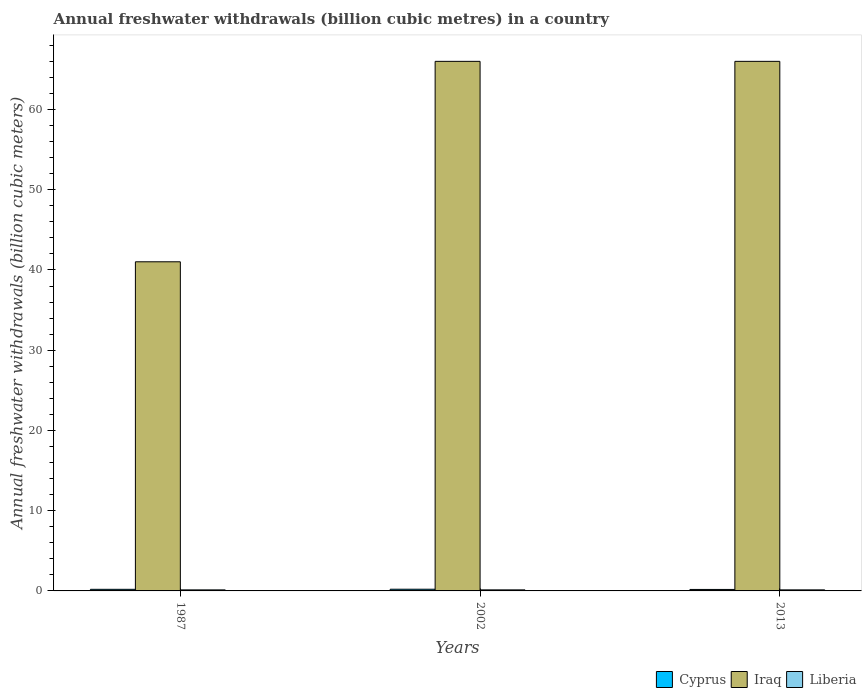How many different coloured bars are there?
Make the answer very short. 3. Are the number of bars per tick equal to the number of legend labels?
Provide a succinct answer. Yes. How many bars are there on the 3rd tick from the left?
Make the answer very short. 3. How many bars are there on the 1st tick from the right?
Your answer should be very brief. 3. In how many cases, is the number of bars for a given year not equal to the number of legend labels?
Your answer should be compact. 0. What is the annual freshwater withdrawals in Iraq in 2013?
Your answer should be compact. 66. Across all years, what is the minimum annual freshwater withdrawals in Liberia?
Offer a terse response. 0.13. In which year was the annual freshwater withdrawals in Cyprus maximum?
Your answer should be compact. 2002. What is the total annual freshwater withdrawals in Cyprus in the graph?
Your answer should be very brief. 0.59. What is the difference between the annual freshwater withdrawals in Liberia in 2002 and the annual freshwater withdrawals in Cyprus in 2013?
Ensure brevity in your answer.  -0.05. What is the average annual freshwater withdrawals in Iraq per year?
Your response must be concise. 57.67. In the year 2002, what is the difference between the annual freshwater withdrawals in Liberia and annual freshwater withdrawals in Iraq?
Provide a short and direct response. -65.87. In how many years, is the annual freshwater withdrawals in Liberia greater than 16 billion cubic meters?
Provide a succinct answer. 0. What is the ratio of the annual freshwater withdrawals in Cyprus in 1987 to that in 2013?
Provide a short and direct response. 1.09. Is the difference between the annual freshwater withdrawals in Liberia in 1987 and 2002 greater than the difference between the annual freshwater withdrawals in Iraq in 1987 and 2002?
Offer a very short reply. Yes. What is the difference between the highest and the second highest annual freshwater withdrawals in Iraq?
Your response must be concise. 0. What is the difference between the highest and the lowest annual freshwater withdrawals in Liberia?
Your response must be concise. 0. In how many years, is the annual freshwater withdrawals in Iraq greater than the average annual freshwater withdrawals in Iraq taken over all years?
Ensure brevity in your answer.  2. Is the sum of the annual freshwater withdrawals in Liberia in 2002 and 2013 greater than the maximum annual freshwater withdrawals in Cyprus across all years?
Your answer should be compact. Yes. What does the 2nd bar from the left in 1987 represents?
Keep it short and to the point. Iraq. What does the 2nd bar from the right in 2002 represents?
Keep it short and to the point. Iraq. Are all the bars in the graph horizontal?
Give a very brief answer. No. How many years are there in the graph?
Ensure brevity in your answer.  3. Does the graph contain any zero values?
Give a very brief answer. No. Does the graph contain grids?
Your response must be concise. No. Where does the legend appear in the graph?
Your answer should be compact. Bottom right. How are the legend labels stacked?
Make the answer very short. Horizontal. What is the title of the graph?
Offer a very short reply. Annual freshwater withdrawals (billion cubic metres) in a country. Does "Low & middle income" appear as one of the legend labels in the graph?
Give a very brief answer. No. What is the label or title of the X-axis?
Provide a succinct answer. Years. What is the label or title of the Y-axis?
Give a very brief answer. Annual freshwater withdrawals (billion cubic meters). What is the Annual freshwater withdrawals (billion cubic meters) of Iraq in 1987?
Your answer should be very brief. 41.02. What is the Annual freshwater withdrawals (billion cubic meters) of Liberia in 1987?
Provide a succinct answer. 0.13. What is the Annual freshwater withdrawals (billion cubic meters) in Cyprus in 2002?
Your answer should be very brief. 0.21. What is the Annual freshwater withdrawals (billion cubic meters) of Iraq in 2002?
Provide a succinct answer. 66. What is the Annual freshwater withdrawals (billion cubic meters) in Liberia in 2002?
Give a very brief answer. 0.13. What is the Annual freshwater withdrawals (billion cubic meters) in Cyprus in 2013?
Ensure brevity in your answer.  0.18. What is the Annual freshwater withdrawals (billion cubic meters) of Liberia in 2013?
Offer a terse response. 0.13. Across all years, what is the maximum Annual freshwater withdrawals (billion cubic meters) of Cyprus?
Your answer should be very brief. 0.21. Across all years, what is the maximum Annual freshwater withdrawals (billion cubic meters) of Iraq?
Your response must be concise. 66. Across all years, what is the maximum Annual freshwater withdrawals (billion cubic meters) in Liberia?
Give a very brief answer. 0.13. Across all years, what is the minimum Annual freshwater withdrawals (billion cubic meters) in Cyprus?
Your response must be concise. 0.18. Across all years, what is the minimum Annual freshwater withdrawals (billion cubic meters) of Iraq?
Offer a very short reply. 41.02. Across all years, what is the minimum Annual freshwater withdrawals (billion cubic meters) in Liberia?
Your answer should be very brief. 0.13. What is the total Annual freshwater withdrawals (billion cubic meters) in Cyprus in the graph?
Provide a short and direct response. 0.59. What is the total Annual freshwater withdrawals (billion cubic meters) of Iraq in the graph?
Make the answer very short. 173.02. What is the total Annual freshwater withdrawals (billion cubic meters) of Liberia in the graph?
Ensure brevity in your answer.  0.39. What is the difference between the Annual freshwater withdrawals (billion cubic meters) of Cyprus in 1987 and that in 2002?
Your answer should be compact. -0.01. What is the difference between the Annual freshwater withdrawals (billion cubic meters) of Iraq in 1987 and that in 2002?
Provide a succinct answer. -24.98. What is the difference between the Annual freshwater withdrawals (billion cubic meters) in Liberia in 1987 and that in 2002?
Keep it short and to the point. -0. What is the difference between the Annual freshwater withdrawals (billion cubic meters) of Cyprus in 1987 and that in 2013?
Provide a short and direct response. 0.02. What is the difference between the Annual freshwater withdrawals (billion cubic meters) of Iraq in 1987 and that in 2013?
Your answer should be compact. -24.98. What is the difference between the Annual freshwater withdrawals (billion cubic meters) of Liberia in 1987 and that in 2013?
Your answer should be compact. -0. What is the difference between the Annual freshwater withdrawals (billion cubic meters) of Cyprus in 2002 and that in 2013?
Ensure brevity in your answer.  0.03. What is the difference between the Annual freshwater withdrawals (billion cubic meters) of Cyprus in 1987 and the Annual freshwater withdrawals (billion cubic meters) of Iraq in 2002?
Your response must be concise. -65.8. What is the difference between the Annual freshwater withdrawals (billion cubic meters) in Cyprus in 1987 and the Annual freshwater withdrawals (billion cubic meters) in Liberia in 2002?
Offer a terse response. 0.07. What is the difference between the Annual freshwater withdrawals (billion cubic meters) of Iraq in 1987 and the Annual freshwater withdrawals (billion cubic meters) of Liberia in 2002?
Provide a succinct answer. 40.89. What is the difference between the Annual freshwater withdrawals (billion cubic meters) in Cyprus in 1987 and the Annual freshwater withdrawals (billion cubic meters) in Iraq in 2013?
Ensure brevity in your answer.  -65.8. What is the difference between the Annual freshwater withdrawals (billion cubic meters) of Cyprus in 1987 and the Annual freshwater withdrawals (billion cubic meters) of Liberia in 2013?
Give a very brief answer. 0.07. What is the difference between the Annual freshwater withdrawals (billion cubic meters) in Iraq in 1987 and the Annual freshwater withdrawals (billion cubic meters) in Liberia in 2013?
Keep it short and to the point. 40.89. What is the difference between the Annual freshwater withdrawals (billion cubic meters) of Cyprus in 2002 and the Annual freshwater withdrawals (billion cubic meters) of Iraq in 2013?
Your answer should be very brief. -65.79. What is the difference between the Annual freshwater withdrawals (billion cubic meters) in Cyprus in 2002 and the Annual freshwater withdrawals (billion cubic meters) in Liberia in 2013?
Provide a short and direct response. 0.08. What is the difference between the Annual freshwater withdrawals (billion cubic meters) in Iraq in 2002 and the Annual freshwater withdrawals (billion cubic meters) in Liberia in 2013?
Provide a short and direct response. 65.87. What is the average Annual freshwater withdrawals (billion cubic meters) in Cyprus per year?
Make the answer very short. 0.2. What is the average Annual freshwater withdrawals (billion cubic meters) in Iraq per year?
Provide a short and direct response. 57.67. What is the average Annual freshwater withdrawals (billion cubic meters) of Liberia per year?
Make the answer very short. 0.13. In the year 1987, what is the difference between the Annual freshwater withdrawals (billion cubic meters) of Cyprus and Annual freshwater withdrawals (billion cubic meters) of Iraq?
Offer a very short reply. -40.82. In the year 1987, what is the difference between the Annual freshwater withdrawals (billion cubic meters) of Cyprus and Annual freshwater withdrawals (billion cubic meters) of Liberia?
Offer a terse response. 0.07. In the year 1987, what is the difference between the Annual freshwater withdrawals (billion cubic meters) in Iraq and Annual freshwater withdrawals (billion cubic meters) in Liberia?
Provide a succinct answer. 40.89. In the year 2002, what is the difference between the Annual freshwater withdrawals (billion cubic meters) of Cyprus and Annual freshwater withdrawals (billion cubic meters) of Iraq?
Ensure brevity in your answer.  -65.79. In the year 2002, what is the difference between the Annual freshwater withdrawals (billion cubic meters) of Cyprus and Annual freshwater withdrawals (billion cubic meters) of Liberia?
Provide a succinct answer. 0.08. In the year 2002, what is the difference between the Annual freshwater withdrawals (billion cubic meters) in Iraq and Annual freshwater withdrawals (billion cubic meters) in Liberia?
Your answer should be very brief. 65.87. In the year 2013, what is the difference between the Annual freshwater withdrawals (billion cubic meters) of Cyprus and Annual freshwater withdrawals (billion cubic meters) of Iraq?
Give a very brief answer. -65.82. In the year 2013, what is the difference between the Annual freshwater withdrawals (billion cubic meters) in Cyprus and Annual freshwater withdrawals (billion cubic meters) in Liberia?
Make the answer very short. 0.05. In the year 2013, what is the difference between the Annual freshwater withdrawals (billion cubic meters) in Iraq and Annual freshwater withdrawals (billion cubic meters) in Liberia?
Ensure brevity in your answer.  65.87. What is the ratio of the Annual freshwater withdrawals (billion cubic meters) in Cyprus in 1987 to that in 2002?
Ensure brevity in your answer.  0.95. What is the ratio of the Annual freshwater withdrawals (billion cubic meters) in Iraq in 1987 to that in 2002?
Give a very brief answer. 0.62. What is the ratio of the Annual freshwater withdrawals (billion cubic meters) of Cyprus in 1987 to that in 2013?
Provide a succinct answer. 1.09. What is the ratio of the Annual freshwater withdrawals (billion cubic meters) of Iraq in 1987 to that in 2013?
Ensure brevity in your answer.  0.62. What is the ratio of the Annual freshwater withdrawals (billion cubic meters) in Cyprus in 2002 to that in 2013?
Provide a succinct answer. 1.14. What is the ratio of the Annual freshwater withdrawals (billion cubic meters) in Liberia in 2002 to that in 2013?
Ensure brevity in your answer.  1. What is the difference between the highest and the second highest Annual freshwater withdrawals (billion cubic meters) in Cyprus?
Provide a short and direct response. 0.01. What is the difference between the highest and the second highest Annual freshwater withdrawals (billion cubic meters) of Iraq?
Make the answer very short. 0. What is the difference between the highest and the lowest Annual freshwater withdrawals (billion cubic meters) of Cyprus?
Make the answer very short. 0.03. What is the difference between the highest and the lowest Annual freshwater withdrawals (billion cubic meters) of Iraq?
Provide a short and direct response. 24.98. What is the difference between the highest and the lowest Annual freshwater withdrawals (billion cubic meters) of Liberia?
Your answer should be very brief. 0. 